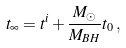Convert formula to latex. <formula><loc_0><loc_0><loc_500><loc_500>t _ { \infty } = t ^ { i } + \frac { M _ { \odot } } { M _ { B H } } t _ { 0 } \, ,</formula> 